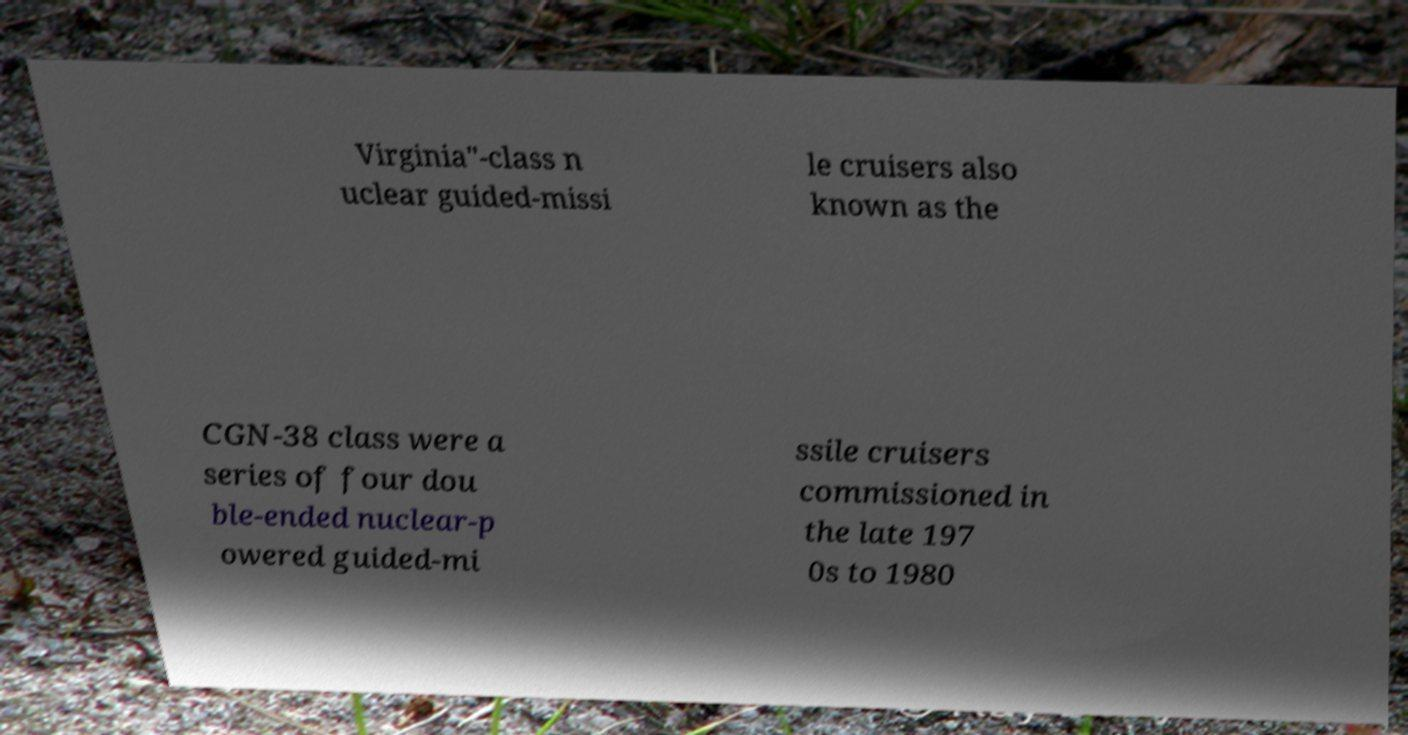Please read and relay the text visible in this image. What does it say? Virginia"-class n uclear guided-missi le cruisers also known as the CGN-38 class were a series of four dou ble-ended nuclear-p owered guided-mi ssile cruisers commissioned in the late 197 0s to 1980 